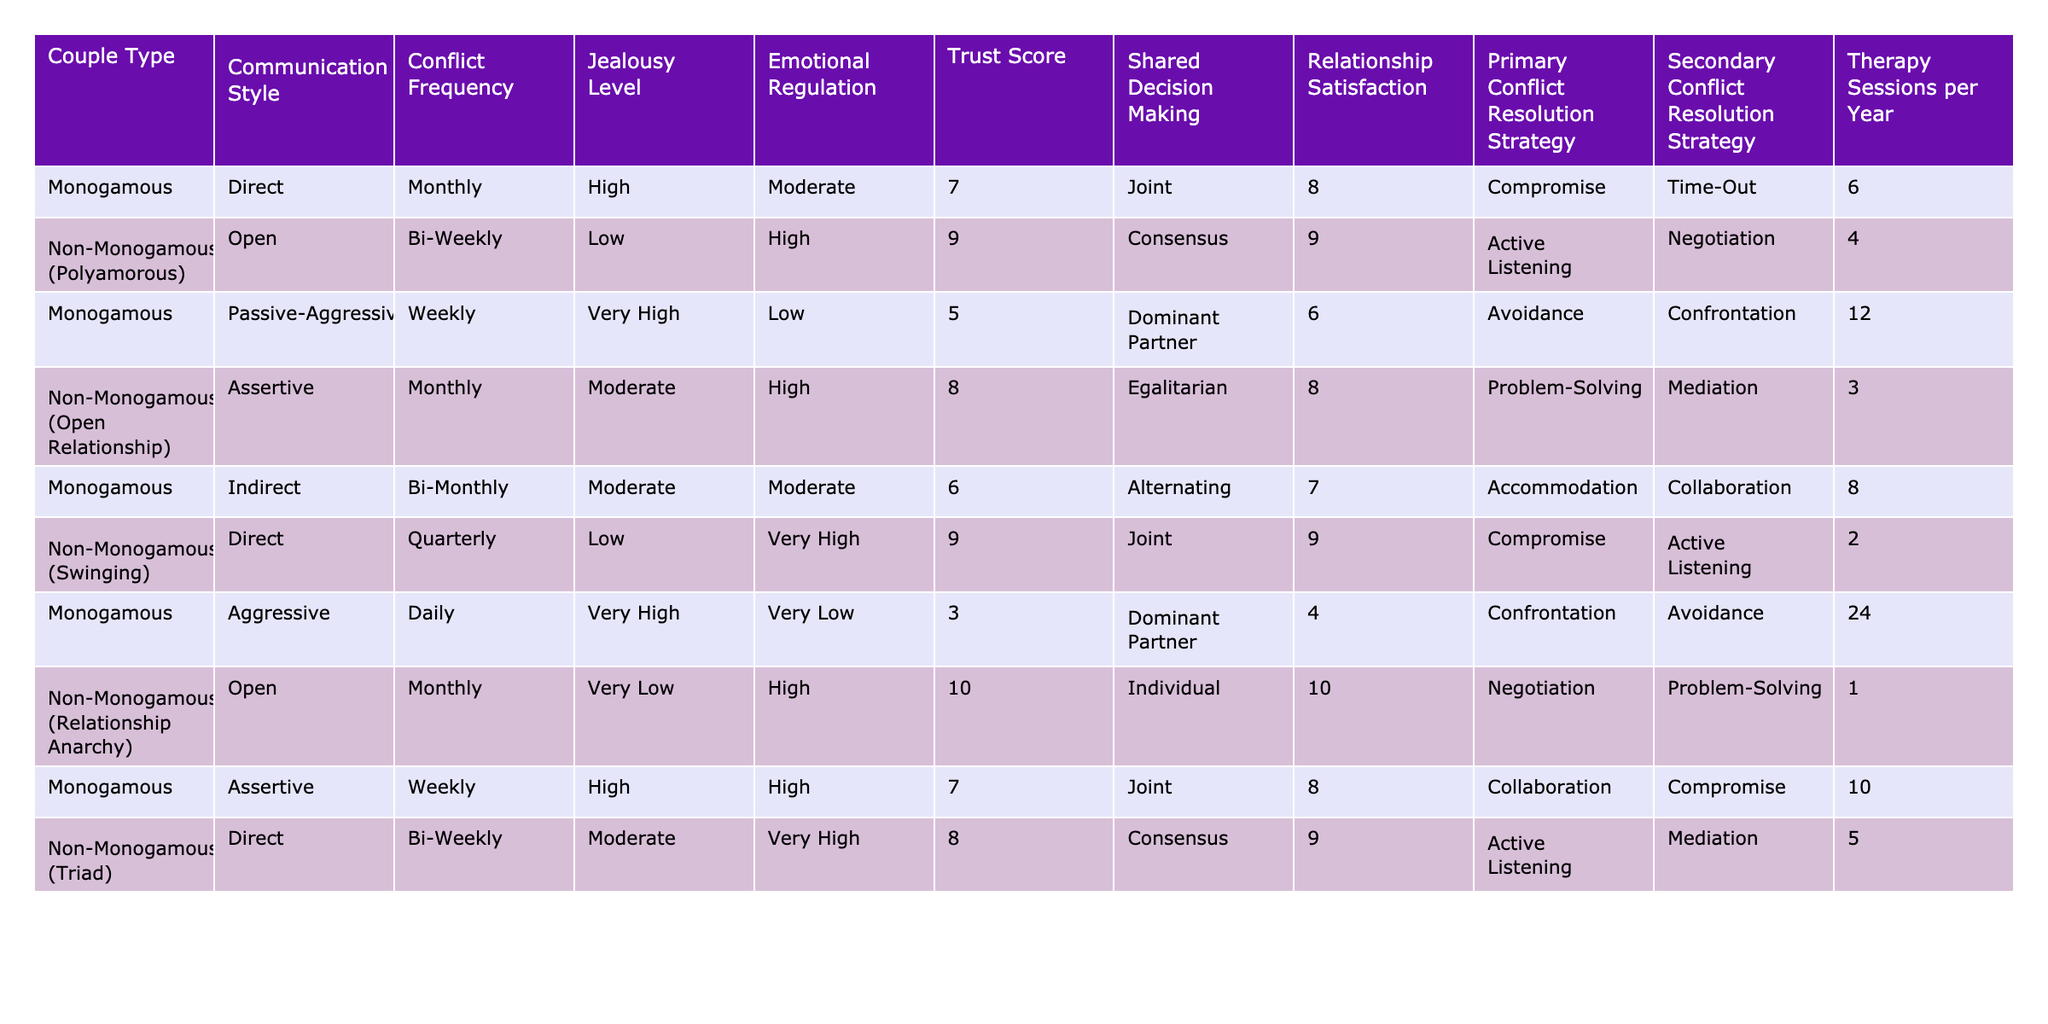What is the conflict frequency for non-monogamous couples in a triad? The conflict frequency for non-monogamous (Triad) couples, as per the table, is specified as bi-weekly.
Answer: Bi-Weekly How many therapy sessions do monogamous couples who use aggressive conflict resolution strategies typically have per year? Monogamous couples using aggressive strategies have 24 therapy sessions per year, as indicated in the table.
Answer: 24 Which couple type has the highest emotional regulation and what is the value? The couple type with the highest emotional regulation is Non-Monogamous (Relationship Anarchy) with a value of High.
Answer: High What is the average trust score for monogamous couples? The trust scores for monogamous couples are 7, 5, 6, 3, and 7. The sum is 28 and when divided by 5 (the number of couples), the average trust score is 5.6.
Answer: 5.6 Do non-monogamous couples generally have a higher relationship satisfaction than monogamous couples? Comparing the relationship satisfaction, Non-Monogamous averages 9, while Monogamous averages 6. This indicates that non-monogamous couples generally have higher satisfaction.
Answer: Yes What is the primary conflict resolution strategy used by non-monogamous (polyamorous) couples, and how does it differ from monogamous (passive-aggressive) couples? Non-monogamous (polyamorous) couples primarily use Active Listening, while monogamous (passive-aggressive) couples use Avoidance. This reflects a difference in their approach to handling conflicts.
Answer: Active Listening Which couple type has the lowest jealousy level and what is that level? The couple type with the lowest jealousy level is Non-Monogamous (Relationship Anarchy) with a value of Very Low.
Answer: Very Low What is the difference in trust scores between passive-aggressive and assertive monogamous couples? The trust score for passive-aggressive couples is 5, while assertive couples have a score of 7. The difference is 7 - 5 = 2.
Answer: 2 Which type of couple has the highest conflict frequency and what is that frequency? The type of couples with the highest conflict frequency is Monogamous (Aggressive) with a daily frequency listed in the table.
Answer: Daily In terms of shared decision making, which couple type tends to have a dominant partner? Monogamous couples characterized as passive-aggressive tend to have a dominant partner as indicated by the shared decision-making column.
Answer: Monogamous (Passive-Aggressive) 